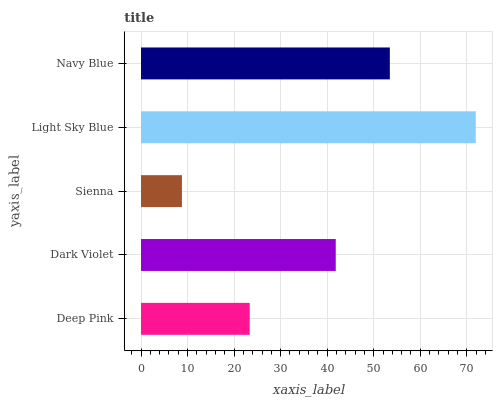Is Sienna the minimum?
Answer yes or no. Yes. Is Light Sky Blue the maximum?
Answer yes or no. Yes. Is Dark Violet the minimum?
Answer yes or no. No. Is Dark Violet the maximum?
Answer yes or no. No. Is Dark Violet greater than Deep Pink?
Answer yes or no. Yes. Is Deep Pink less than Dark Violet?
Answer yes or no. Yes. Is Deep Pink greater than Dark Violet?
Answer yes or no. No. Is Dark Violet less than Deep Pink?
Answer yes or no. No. Is Dark Violet the high median?
Answer yes or no. Yes. Is Dark Violet the low median?
Answer yes or no. Yes. Is Deep Pink the high median?
Answer yes or no. No. Is Navy Blue the low median?
Answer yes or no. No. 